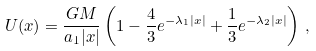<formula> <loc_0><loc_0><loc_500><loc_500>U ( x ) = \frac { G M } { a _ { 1 } | x | } \left ( 1 - \frac { 4 } { 3 } e ^ { - \lambda _ { 1 } | x | } + \frac { 1 } { 3 } e ^ { - \lambda _ { 2 } | x | } \right ) \, ,</formula> 